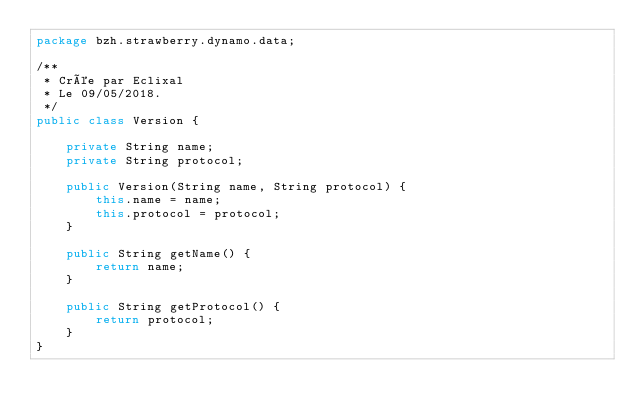Convert code to text. <code><loc_0><loc_0><loc_500><loc_500><_Java_>package bzh.strawberry.dynamo.data;

/**
 * Crée par Eclixal
 * Le 09/05/2018.
 */
public class Version {

    private String name;
    private String protocol;

    public Version(String name, String protocol) {
        this.name = name;
        this.protocol = protocol;
    }

    public String getName() {
        return name;
    }

    public String getProtocol() {
        return protocol;
    }
}</code> 